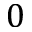Convert formula to latex. <formula><loc_0><loc_0><loc_500><loc_500>0</formula> 